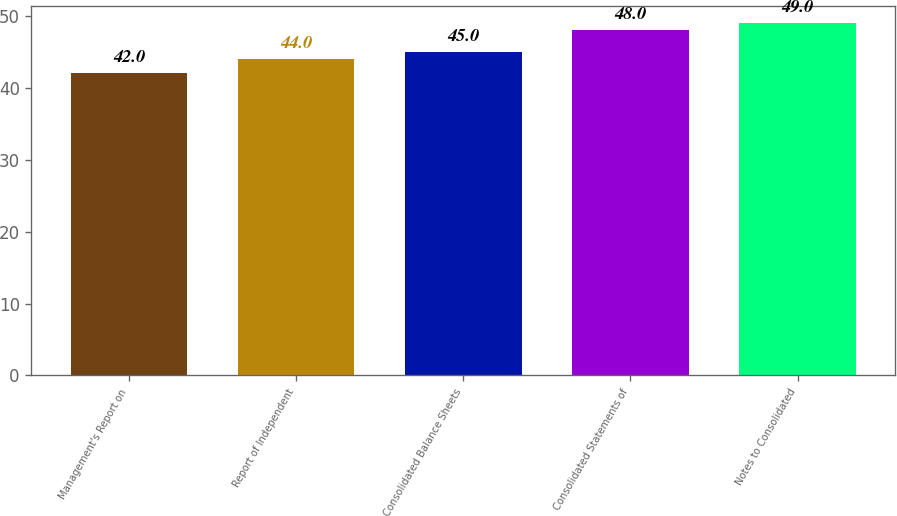<chart> <loc_0><loc_0><loc_500><loc_500><bar_chart><fcel>Management's Report on<fcel>Report of Independent<fcel>Consolidated Balance Sheets<fcel>Consolidated Statements of<fcel>Notes to Consolidated<nl><fcel>42<fcel>44<fcel>45<fcel>48<fcel>49<nl></chart> 